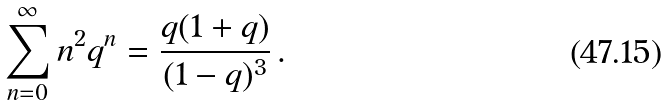Convert formula to latex. <formula><loc_0><loc_0><loc_500><loc_500>\sum _ { n = 0 } ^ { \infty } n ^ { 2 } q ^ { n } = \frac { q ( 1 + q ) } { ( 1 - q ) ^ { 3 } } \, .</formula> 